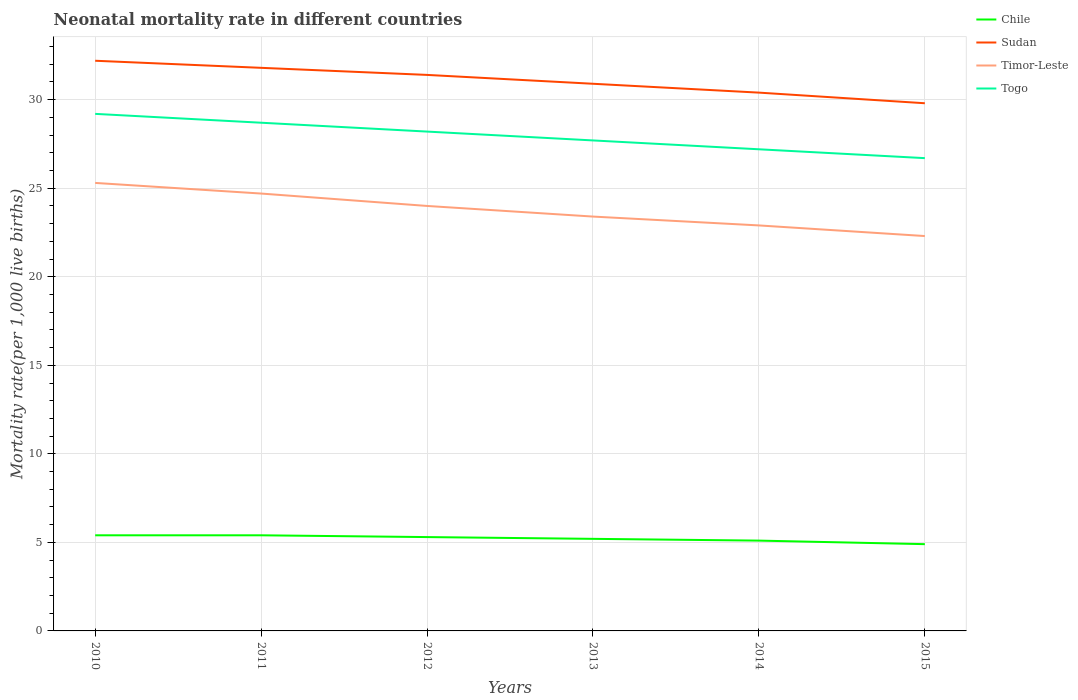How many different coloured lines are there?
Provide a short and direct response. 4. Is the number of lines equal to the number of legend labels?
Make the answer very short. Yes. Across all years, what is the maximum neonatal mortality rate in Sudan?
Make the answer very short. 29.8. In which year was the neonatal mortality rate in Togo maximum?
Ensure brevity in your answer.  2015. What is the total neonatal mortality rate in Timor-Leste in the graph?
Offer a terse response. 2.4. What is the difference between the highest and the second highest neonatal mortality rate in Timor-Leste?
Ensure brevity in your answer.  3. Does the graph contain any zero values?
Provide a short and direct response. No. How many legend labels are there?
Ensure brevity in your answer.  4. What is the title of the graph?
Your answer should be compact. Neonatal mortality rate in different countries. Does "Greenland" appear as one of the legend labels in the graph?
Your answer should be very brief. No. What is the label or title of the X-axis?
Give a very brief answer. Years. What is the label or title of the Y-axis?
Make the answer very short. Mortality rate(per 1,0 live births). What is the Mortality rate(per 1,000 live births) of Chile in 2010?
Keep it short and to the point. 5.4. What is the Mortality rate(per 1,000 live births) in Sudan in 2010?
Make the answer very short. 32.2. What is the Mortality rate(per 1,000 live births) in Timor-Leste in 2010?
Offer a terse response. 25.3. What is the Mortality rate(per 1,000 live births) of Togo in 2010?
Make the answer very short. 29.2. What is the Mortality rate(per 1,000 live births) of Sudan in 2011?
Your response must be concise. 31.8. What is the Mortality rate(per 1,000 live births) of Timor-Leste in 2011?
Give a very brief answer. 24.7. What is the Mortality rate(per 1,000 live births) of Togo in 2011?
Offer a terse response. 28.7. What is the Mortality rate(per 1,000 live births) of Sudan in 2012?
Make the answer very short. 31.4. What is the Mortality rate(per 1,000 live births) of Togo in 2012?
Keep it short and to the point. 28.2. What is the Mortality rate(per 1,000 live births) in Sudan in 2013?
Your response must be concise. 30.9. What is the Mortality rate(per 1,000 live births) in Timor-Leste in 2013?
Your answer should be very brief. 23.4. What is the Mortality rate(per 1,000 live births) of Togo in 2013?
Provide a succinct answer. 27.7. What is the Mortality rate(per 1,000 live births) in Chile in 2014?
Ensure brevity in your answer.  5.1. What is the Mortality rate(per 1,000 live births) of Sudan in 2014?
Offer a very short reply. 30.4. What is the Mortality rate(per 1,000 live births) of Timor-Leste in 2014?
Keep it short and to the point. 22.9. What is the Mortality rate(per 1,000 live births) in Togo in 2014?
Offer a very short reply. 27.2. What is the Mortality rate(per 1,000 live births) in Chile in 2015?
Make the answer very short. 4.9. What is the Mortality rate(per 1,000 live births) in Sudan in 2015?
Ensure brevity in your answer.  29.8. What is the Mortality rate(per 1,000 live births) in Timor-Leste in 2015?
Keep it short and to the point. 22.3. What is the Mortality rate(per 1,000 live births) in Togo in 2015?
Offer a very short reply. 26.7. Across all years, what is the maximum Mortality rate(per 1,000 live births) of Chile?
Make the answer very short. 5.4. Across all years, what is the maximum Mortality rate(per 1,000 live births) of Sudan?
Your response must be concise. 32.2. Across all years, what is the maximum Mortality rate(per 1,000 live births) of Timor-Leste?
Give a very brief answer. 25.3. Across all years, what is the maximum Mortality rate(per 1,000 live births) in Togo?
Offer a terse response. 29.2. Across all years, what is the minimum Mortality rate(per 1,000 live births) of Chile?
Your answer should be compact. 4.9. Across all years, what is the minimum Mortality rate(per 1,000 live births) in Sudan?
Your answer should be very brief. 29.8. Across all years, what is the minimum Mortality rate(per 1,000 live births) of Timor-Leste?
Give a very brief answer. 22.3. Across all years, what is the minimum Mortality rate(per 1,000 live births) in Togo?
Keep it short and to the point. 26.7. What is the total Mortality rate(per 1,000 live births) in Chile in the graph?
Offer a very short reply. 31.3. What is the total Mortality rate(per 1,000 live births) in Sudan in the graph?
Offer a very short reply. 186.5. What is the total Mortality rate(per 1,000 live births) of Timor-Leste in the graph?
Ensure brevity in your answer.  142.6. What is the total Mortality rate(per 1,000 live births) in Togo in the graph?
Give a very brief answer. 167.7. What is the difference between the Mortality rate(per 1,000 live births) in Chile in 2010 and that in 2011?
Your answer should be very brief. 0. What is the difference between the Mortality rate(per 1,000 live births) in Sudan in 2010 and that in 2011?
Offer a very short reply. 0.4. What is the difference between the Mortality rate(per 1,000 live births) in Togo in 2010 and that in 2011?
Offer a very short reply. 0.5. What is the difference between the Mortality rate(per 1,000 live births) of Sudan in 2010 and that in 2012?
Provide a short and direct response. 0.8. What is the difference between the Mortality rate(per 1,000 live births) of Togo in 2010 and that in 2012?
Provide a succinct answer. 1. What is the difference between the Mortality rate(per 1,000 live births) in Sudan in 2010 and that in 2013?
Make the answer very short. 1.3. What is the difference between the Mortality rate(per 1,000 live births) of Togo in 2010 and that in 2013?
Your answer should be very brief. 1.5. What is the difference between the Mortality rate(per 1,000 live births) in Chile in 2010 and that in 2014?
Ensure brevity in your answer.  0.3. What is the difference between the Mortality rate(per 1,000 live births) of Sudan in 2010 and that in 2014?
Your answer should be compact. 1.8. What is the difference between the Mortality rate(per 1,000 live births) in Chile in 2010 and that in 2015?
Provide a succinct answer. 0.5. What is the difference between the Mortality rate(per 1,000 live births) of Timor-Leste in 2010 and that in 2015?
Your response must be concise. 3. What is the difference between the Mortality rate(per 1,000 live births) in Togo in 2010 and that in 2015?
Keep it short and to the point. 2.5. What is the difference between the Mortality rate(per 1,000 live births) of Chile in 2011 and that in 2012?
Your answer should be very brief. 0.1. What is the difference between the Mortality rate(per 1,000 live births) of Sudan in 2011 and that in 2012?
Your answer should be very brief. 0.4. What is the difference between the Mortality rate(per 1,000 live births) of Timor-Leste in 2011 and that in 2012?
Provide a succinct answer. 0.7. What is the difference between the Mortality rate(per 1,000 live births) in Togo in 2011 and that in 2013?
Provide a succinct answer. 1. What is the difference between the Mortality rate(per 1,000 live births) in Sudan in 2011 and that in 2014?
Make the answer very short. 1.4. What is the difference between the Mortality rate(per 1,000 live births) of Chile in 2011 and that in 2015?
Your answer should be very brief. 0.5. What is the difference between the Mortality rate(per 1,000 live births) of Timor-Leste in 2011 and that in 2015?
Offer a terse response. 2.4. What is the difference between the Mortality rate(per 1,000 live births) in Sudan in 2012 and that in 2013?
Your answer should be compact. 0.5. What is the difference between the Mortality rate(per 1,000 live births) in Chile in 2012 and that in 2014?
Your response must be concise. 0.2. What is the difference between the Mortality rate(per 1,000 live births) of Timor-Leste in 2012 and that in 2014?
Keep it short and to the point. 1.1. What is the difference between the Mortality rate(per 1,000 live births) in Togo in 2012 and that in 2014?
Your answer should be compact. 1. What is the difference between the Mortality rate(per 1,000 live births) in Sudan in 2012 and that in 2015?
Make the answer very short. 1.6. What is the difference between the Mortality rate(per 1,000 live births) of Chile in 2013 and that in 2014?
Make the answer very short. 0.1. What is the difference between the Mortality rate(per 1,000 live births) in Sudan in 2013 and that in 2014?
Make the answer very short. 0.5. What is the difference between the Mortality rate(per 1,000 live births) of Togo in 2013 and that in 2014?
Offer a very short reply. 0.5. What is the difference between the Mortality rate(per 1,000 live births) in Togo in 2013 and that in 2015?
Keep it short and to the point. 1. What is the difference between the Mortality rate(per 1,000 live births) in Sudan in 2014 and that in 2015?
Keep it short and to the point. 0.6. What is the difference between the Mortality rate(per 1,000 live births) of Chile in 2010 and the Mortality rate(per 1,000 live births) of Sudan in 2011?
Offer a very short reply. -26.4. What is the difference between the Mortality rate(per 1,000 live births) of Chile in 2010 and the Mortality rate(per 1,000 live births) of Timor-Leste in 2011?
Provide a short and direct response. -19.3. What is the difference between the Mortality rate(per 1,000 live births) of Chile in 2010 and the Mortality rate(per 1,000 live births) of Togo in 2011?
Ensure brevity in your answer.  -23.3. What is the difference between the Mortality rate(per 1,000 live births) in Sudan in 2010 and the Mortality rate(per 1,000 live births) in Timor-Leste in 2011?
Offer a terse response. 7.5. What is the difference between the Mortality rate(per 1,000 live births) in Timor-Leste in 2010 and the Mortality rate(per 1,000 live births) in Togo in 2011?
Ensure brevity in your answer.  -3.4. What is the difference between the Mortality rate(per 1,000 live births) of Chile in 2010 and the Mortality rate(per 1,000 live births) of Timor-Leste in 2012?
Offer a very short reply. -18.6. What is the difference between the Mortality rate(per 1,000 live births) of Chile in 2010 and the Mortality rate(per 1,000 live births) of Togo in 2012?
Give a very brief answer. -22.8. What is the difference between the Mortality rate(per 1,000 live births) in Timor-Leste in 2010 and the Mortality rate(per 1,000 live births) in Togo in 2012?
Your response must be concise. -2.9. What is the difference between the Mortality rate(per 1,000 live births) in Chile in 2010 and the Mortality rate(per 1,000 live births) in Sudan in 2013?
Provide a succinct answer. -25.5. What is the difference between the Mortality rate(per 1,000 live births) of Chile in 2010 and the Mortality rate(per 1,000 live births) of Timor-Leste in 2013?
Your response must be concise. -18. What is the difference between the Mortality rate(per 1,000 live births) in Chile in 2010 and the Mortality rate(per 1,000 live births) in Togo in 2013?
Keep it short and to the point. -22.3. What is the difference between the Mortality rate(per 1,000 live births) of Timor-Leste in 2010 and the Mortality rate(per 1,000 live births) of Togo in 2013?
Ensure brevity in your answer.  -2.4. What is the difference between the Mortality rate(per 1,000 live births) in Chile in 2010 and the Mortality rate(per 1,000 live births) in Timor-Leste in 2014?
Offer a terse response. -17.5. What is the difference between the Mortality rate(per 1,000 live births) in Chile in 2010 and the Mortality rate(per 1,000 live births) in Togo in 2014?
Your response must be concise. -21.8. What is the difference between the Mortality rate(per 1,000 live births) in Timor-Leste in 2010 and the Mortality rate(per 1,000 live births) in Togo in 2014?
Offer a terse response. -1.9. What is the difference between the Mortality rate(per 1,000 live births) in Chile in 2010 and the Mortality rate(per 1,000 live births) in Sudan in 2015?
Keep it short and to the point. -24.4. What is the difference between the Mortality rate(per 1,000 live births) of Chile in 2010 and the Mortality rate(per 1,000 live births) of Timor-Leste in 2015?
Give a very brief answer. -16.9. What is the difference between the Mortality rate(per 1,000 live births) in Chile in 2010 and the Mortality rate(per 1,000 live births) in Togo in 2015?
Ensure brevity in your answer.  -21.3. What is the difference between the Mortality rate(per 1,000 live births) of Sudan in 2010 and the Mortality rate(per 1,000 live births) of Togo in 2015?
Provide a succinct answer. 5.5. What is the difference between the Mortality rate(per 1,000 live births) in Timor-Leste in 2010 and the Mortality rate(per 1,000 live births) in Togo in 2015?
Your answer should be compact. -1.4. What is the difference between the Mortality rate(per 1,000 live births) in Chile in 2011 and the Mortality rate(per 1,000 live births) in Timor-Leste in 2012?
Provide a succinct answer. -18.6. What is the difference between the Mortality rate(per 1,000 live births) in Chile in 2011 and the Mortality rate(per 1,000 live births) in Togo in 2012?
Offer a terse response. -22.8. What is the difference between the Mortality rate(per 1,000 live births) of Sudan in 2011 and the Mortality rate(per 1,000 live births) of Timor-Leste in 2012?
Your answer should be very brief. 7.8. What is the difference between the Mortality rate(per 1,000 live births) in Sudan in 2011 and the Mortality rate(per 1,000 live births) in Togo in 2012?
Make the answer very short. 3.6. What is the difference between the Mortality rate(per 1,000 live births) of Chile in 2011 and the Mortality rate(per 1,000 live births) of Sudan in 2013?
Ensure brevity in your answer.  -25.5. What is the difference between the Mortality rate(per 1,000 live births) in Chile in 2011 and the Mortality rate(per 1,000 live births) in Togo in 2013?
Provide a succinct answer. -22.3. What is the difference between the Mortality rate(per 1,000 live births) in Sudan in 2011 and the Mortality rate(per 1,000 live births) in Togo in 2013?
Offer a very short reply. 4.1. What is the difference between the Mortality rate(per 1,000 live births) of Chile in 2011 and the Mortality rate(per 1,000 live births) of Timor-Leste in 2014?
Keep it short and to the point. -17.5. What is the difference between the Mortality rate(per 1,000 live births) in Chile in 2011 and the Mortality rate(per 1,000 live births) in Togo in 2014?
Provide a short and direct response. -21.8. What is the difference between the Mortality rate(per 1,000 live births) of Chile in 2011 and the Mortality rate(per 1,000 live births) of Sudan in 2015?
Your answer should be compact. -24.4. What is the difference between the Mortality rate(per 1,000 live births) of Chile in 2011 and the Mortality rate(per 1,000 live births) of Timor-Leste in 2015?
Keep it short and to the point. -16.9. What is the difference between the Mortality rate(per 1,000 live births) of Chile in 2011 and the Mortality rate(per 1,000 live births) of Togo in 2015?
Your answer should be compact. -21.3. What is the difference between the Mortality rate(per 1,000 live births) of Sudan in 2011 and the Mortality rate(per 1,000 live births) of Timor-Leste in 2015?
Offer a very short reply. 9.5. What is the difference between the Mortality rate(per 1,000 live births) of Sudan in 2011 and the Mortality rate(per 1,000 live births) of Togo in 2015?
Provide a succinct answer. 5.1. What is the difference between the Mortality rate(per 1,000 live births) of Chile in 2012 and the Mortality rate(per 1,000 live births) of Sudan in 2013?
Offer a very short reply. -25.6. What is the difference between the Mortality rate(per 1,000 live births) of Chile in 2012 and the Mortality rate(per 1,000 live births) of Timor-Leste in 2013?
Give a very brief answer. -18.1. What is the difference between the Mortality rate(per 1,000 live births) in Chile in 2012 and the Mortality rate(per 1,000 live births) in Togo in 2013?
Give a very brief answer. -22.4. What is the difference between the Mortality rate(per 1,000 live births) of Timor-Leste in 2012 and the Mortality rate(per 1,000 live births) of Togo in 2013?
Provide a short and direct response. -3.7. What is the difference between the Mortality rate(per 1,000 live births) in Chile in 2012 and the Mortality rate(per 1,000 live births) in Sudan in 2014?
Your answer should be compact. -25.1. What is the difference between the Mortality rate(per 1,000 live births) of Chile in 2012 and the Mortality rate(per 1,000 live births) of Timor-Leste in 2014?
Provide a short and direct response. -17.6. What is the difference between the Mortality rate(per 1,000 live births) of Chile in 2012 and the Mortality rate(per 1,000 live births) of Togo in 2014?
Your answer should be very brief. -21.9. What is the difference between the Mortality rate(per 1,000 live births) of Sudan in 2012 and the Mortality rate(per 1,000 live births) of Togo in 2014?
Ensure brevity in your answer.  4.2. What is the difference between the Mortality rate(per 1,000 live births) in Chile in 2012 and the Mortality rate(per 1,000 live births) in Sudan in 2015?
Your answer should be compact. -24.5. What is the difference between the Mortality rate(per 1,000 live births) of Chile in 2012 and the Mortality rate(per 1,000 live births) of Togo in 2015?
Offer a very short reply. -21.4. What is the difference between the Mortality rate(per 1,000 live births) of Sudan in 2012 and the Mortality rate(per 1,000 live births) of Timor-Leste in 2015?
Offer a very short reply. 9.1. What is the difference between the Mortality rate(per 1,000 live births) in Chile in 2013 and the Mortality rate(per 1,000 live births) in Sudan in 2014?
Ensure brevity in your answer.  -25.2. What is the difference between the Mortality rate(per 1,000 live births) in Chile in 2013 and the Mortality rate(per 1,000 live births) in Timor-Leste in 2014?
Give a very brief answer. -17.7. What is the difference between the Mortality rate(per 1,000 live births) in Chile in 2013 and the Mortality rate(per 1,000 live births) in Togo in 2014?
Offer a terse response. -22. What is the difference between the Mortality rate(per 1,000 live births) of Sudan in 2013 and the Mortality rate(per 1,000 live births) of Timor-Leste in 2014?
Your answer should be very brief. 8. What is the difference between the Mortality rate(per 1,000 live births) of Chile in 2013 and the Mortality rate(per 1,000 live births) of Sudan in 2015?
Keep it short and to the point. -24.6. What is the difference between the Mortality rate(per 1,000 live births) in Chile in 2013 and the Mortality rate(per 1,000 live births) in Timor-Leste in 2015?
Offer a very short reply. -17.1. What is the difference between the Mortality rate(per 1,000 live births) of Chile in 2013 and the Mortality rate(per 1,000 live births) of Togo in 2015?
Provide a short and direct response. -21.5. What is the difference between the Mortality rate(per 1,000 live births) in Sudan in 2013 and the Mortality rate(per 1,000 live births) in Timor-Leste in 2015?
Ensure brevity in your answer.  8.6. What is the difference between the Mortality rate(per 1,000 live births) in Timor-Leste in 2013 and the Mortality rate(per 1,000 live births) in Togo in 2015?
Your answer should be very brief. -3.3. What is the difference between the Mortality rate(per 1,000 live births) of Chile in 2014 and the Mortality rate(per 1,000 live births) of Sudan in 2015?
Offer a terse response. -24.7. What is the difference between the Mortality rate(per 1,000 live births) in Chile in 2014 and the Mortality rate(per 1,000 live births) in Timor-Leste in 2015?
Provide a succinct answer. -17.2. What is the difference between the Mortality rate(per 1,000 live births) in Chile in 2014 and the Mortality rate(per 1,000 live births) in Togo in 2015?
Your answer should be very brief. -21.6. What is the difference between the Mortality rate(per 1,000 live births) in Sudan in 2014 and the Mortality rate(per 1,000 live births) in Timor-Leste in 2015?
Give a very brief answer. 8.1. What is the difference between the Mortality rate(per 1,000 live births) of Sudan in 2014 and the Mortality rate(per 1,000 live births) of Togo in 2015?
Keep it short and to the point. 3.7. What is the difference between the Mortality rate(per 1,000 live births) of Timor-Leste in 2014 and the Mortality rate(per 1,000 live births) of Togo in 2015?
Provide a succinct answer. -3.8. What is the average Mortality rate(per 1,000 live births) of Chile per year?
Make the answer very short. 5.22. What is the average Mortality rate(per 1,000 live births) of Sudan per year?
Ensure brevity in your answer.  31.08. What is the average Mortality rate(per 1,000 live births) of Timor-Leste per year?
Keep it short and to the point. 23.77. What is the average Mortality rate(per 1,000 live births) of Togo per year?
Offer a very short reply. 27.95. In the year 2010, what is the difference between the Mortality rate(per 1,000 live births) of Chile and Mortality rate(per 1,000 live births) of Sudan?
Your answer should be compact. -26.8. In the year 2010, what is the difference between the Mortality rate(per 1,000 live births) in Chile and Mortality rate(per 1,000 live births) in Timor-Leste?
Keep it short and to the point. -19.9. In the year 2010, what is the difference between the Mortality rate(per 1,000 live births) of Chile and Mortality rate(per 1,000 live births) of Togo?
Your answer should be very brief. -23.8. In the year 2010, what is the difference between the Mortality rate(per 1,000 live births) of Sudan and Mortality rate(per 1,000 live births) of Timor-Leste?
Your answer should be very brief. 6.9. In the year 2010, what is the difference between the Mortality rate(per 1,000 live births) in Sudan and Mortality rate(per 1,000 live births) in Togo?
Offer a very short reply. 3. In the year 2011, what is the difference between the Mortality rate(per 1,000 live births) of Chile and Mortality rate(per 1,000 live births) of Sudan?
Give a very brief answer. -26.4. In the year 2011, what is the difference between the Mortality rate(per 1,000 live births) of Chile and Mortality rate(per 1,000 live births) of Timor-Leste?
Your answer should be very brief. -19.3. In the year 2011, what is the difference between the Mortality rate(per 1,000 live births) of Chile and Mortality rate(per 1,000 live births) of Togo?
Your answer should be very brief. -23.3. In the year 2011, what is the difference between the Mortality rate(per 1,000 live births) of Timor-Leste and Mortality rate(per 1,000 live births) of Togo?
Keep it short and to the point. -4. In the year 2012, what is the difference between the Mortality rate(per 1,000 live births) in Chile and Mortality rate(per 1,000 live births) in Sudan?
Give a very brief answer. -26.1. In the year 2012, what is the difference between the Mortality rate(per 1,000 live births) of Chile and Mortality rate(per 1,000 live births) of Timor-Leste?
Provide a succinct answer. -18.7. In the year 2012, what is the difference between the Mortality rate(per 1,000 live births) in Chile and Mortality rate(per 1,000 live births) in Togo?
Give a very brief answer. -22.9. In the year 2012, what is the difference between the Mortality rate(per 1,000 live births) of Timor-Leste and Mortality rate(per 1,000 live births) of Togo?
Your answer should be very brief. -4.2. In the year 2013, what is the difference between the Mortality rate(per 1,000 live births) of Chile and Mortality rate(per 1,000 live births) of Sudan?
Ensure brevity in your answer.  -25.7. In the year 2013, what is the difference between the Mortality rate(per 1,000 live births) in Chile and Mortality rate(per 1,000 live births) in Timor-Leste?
Provide a short and direct response. -18.2. In the year 2013, what is the difference between the Mortality rate(per 1,000 live births) in Chile and Mortality rate(per 1,000 live births) in Togo?
Your response must be concise. -22.5. In the year 2013, what is the difference between the Mortality rate(per 1,000 live births) in Sudan and Mortality rate(per 1,000 live births) in Timor-Leste?
Your answer should be very brief. 7.5. In the year 2013, what is the difference between the Mortality rate(per 1,000 live births) in Timor-Leste and Mortality rate(per 1,000 live births) in Togo?
Offer a very short reply. -4.3. In the year 2014, what is the difference between the Mortality rate(per 1,000 live births) in Chile and Mortality rate(per 1,000 live births) in Sudan?
Ensure brevity in your answer.  -25.3. In the year 2014, what is the difference between the Mortality rate(per 1,000 live births) of Chile and Mortality rate(per 1,000 live births) of Timor-Leste?
Your answer should be very brief. -17.8. In the year 2014, what is the difference between the Mortality rate(per 1,000 live births) of Chile and Mortality rate(per 1,000 live births) of Togo?
Your answer should be very brief. -22.1. In the year 2014, what is the difference between the Mortality rate(per 1,000 live births) in Timor-Leste and Mortality rate(per 1,000 live births) in Togo?
Make the answer very short. -4.3. In the year 2015, what is the difference between the Mortality rate(per 1,000 live births) in Chile and Mortality rate(per 1,000 live births) in Sudan?
Offer a terse response. -24.9. In the year 2015, what is the difference between the Mortality rate(per 1,000 live births) of Chile and Mortality rate(per 1,000 live births) of Timor-Leste?
Give a very brief answer. -17.4. In the year 2015, what is the difference between the Mortality rate(per 1,000 live births) in Chile and Mortality rate(per 1,000 live births) in Togo?
Make the answer very short. -21.8. In the year 2015, what is the difference between the Mortality rate(per 1,000 live births) of Sudan and Mortality rate(per 1,000 live births) of Timor-Leste?
Your answer should be compact. 7.5. In the year 2015, what is the difference between the Mortality rate(per 1,000 live births) of Sudan and Mortality rate(per 1,000 live births) of Togo?
Provide a succinct answer. 3.1. What is the ratio of the Mortality rate(per 1,000 live births) in Chile in 2010 to that in 2011?
Offer a very short reply. 1. What is the ratio of the Mortality rate(per 1,000 live births) of Sudan in 2010 to that in 2011?
Your answer should be very brief. 1.01. What is the ratio of the Mortality rate(per 1,000 live births) of Timor-Leste in 2010 to that in 2011?
Offer a terse response. 1.02. What is the ratio of the Mortality rate(per 1,000 live births) of Togo in 2010 to that in 2011?
Your response must be concise. 1.02. What is the ratio of the Mortality rate(per 1,000 live births) of Chile in 2010 to that in 2012?
Ensure brevity in your answer.  1.02. What is the ratio of the Mortality rate(per 1,000 live births) in Sudan in 2010 to that in 2012?
Give a very brief answer. 1.03. What is the ratio of the Mortality rate(per 1,000 live births) in Timor-Leste in 2010 to that in 2012?
Make the answer very short. 1.05. What is the ratio of the Mortality rate(per 1,000 live births) of Togo in 2010 to that in 2012?
Make the answer very short. 1.04. What is the ratio of the Mortality rate(per 1,000 live births) of Sudan in 2010 to that in 2013?
Ensure brevity in your answer.  1.04. What is the ratio of the Mortality rate(per 1,000 live births) of Timor-Leste in 2010 to that in 2013?
Your answer should be compact. 1.08. What is the ratio of the Mortality rate(per 1,000 live births) of Togo in 2010 to that in 2013?
Provide a succinct answer. 1.05. What is the ratio of the Mortality rate(per 1,000 live births) of Chile in 2010 to that in 2014?
Offer a terse response. 1.06. What is the ratio of the Mortality rate(per 1,000 live births) of Sudan in 2010 to that in 2014?
Offer a terse response. 1.06. What is the ratio of the Mortality rate(per 1,000 live births) of Timor-Leste in 2010 to that in 2014?
Your answer should be very brief. 1.1. What is the ratio of the Mortality rate(per 1,000 live births) of Togo in 2010 to that in 2014?
Provide a short and direct response. 1.07. What is the ratio of the Mortality rate(per 1,000 live births) in Chile in 2010 to that in 2015?
Ensure brevity in your answer.  1.1. What is the ratio of the Mortality rate(per 1,000 live births) in Sudan in 2010 to that in 2015?
Your answer should be compact. 1.08. What is the ratio of the Mortality rate(per 1,000 live births) of Timor-Leste in 2010 to that in 2015?
Provide a short and direct response. 1.13. What is the ratio of the Mortality rate(per 1,000 live births) in Togo in 2010 to that in 2015?
Your answer should be compact. 1.09. What is the ratio of the Mortality rate(per 1,000 live births) of Chile in 2011 to that in 2012?
Your response must be concise. 1.02. What is the ratio of the Mortality rate(per 1,000 live births) in Sudan in 2011 to that in 2012?
Ensure brevity in your answer.  1.01. What is the ratio of the Mortality rate(per 1,000 live births) in Timor-Leste in 2011 to that in 2012?
Provide a succinct answer. 1.03. What is the ratio of the Mortality rate(per 1,000 live births) in Togo in 2011 to that in 2012?
Offer a very short reply. 1.02. What is the ratio of the Mortality rate(per 1,000 live births) in Chile in 2011 to that in 2013?
Your answer should be compact. 1.04. What is the ratio of the Mortality rate(per 1,000 live births) of Sudan in 2011 to that in 2013?
Your response must be concise. 1.03. What is the ratio of the Mortality rate(per 1,000 live births) in Timor-Leste in 2011 to that in 2013?
Provide a succinct answer. 1.06. What is the ratio of the Mortality rate(per 1,000 live births) in Togo in 2011 to that in 2013?
Offer a very short reply. 1.04. What is the ratio of the Mortality rate(per 1,000 live births) in Chile in 2011 to that in 2014?
Keep it short and to the point. 1.06. What is the ratio of the Mortality rate(per 1,000 live births) of Sudan in 2011 to that in 2014?
Keep it short and to the point. 1.05. What is the ratio of the Mortality rate(per 1,000 live births) in Timor-Leste in 2011 to that in 2014?
Offer a very short reply. 1.08. What is the ratio of the Mortality rate(per 1,000 live births) of Togo in 2011 to that in 2014?
Provide a short and direct response. 1.06. What is the ratio of the Mortality rate(per 1,000 live births) of Chile in 2011 to that in 2015?
Make the answer very short. 1.1. What is the ratio of the Mortality rate(per 1,000 live births) of Sudan in 2011 to that in 2015?
Provide a short and direct response. 1.07. What is the ratio of the Mortality rate(per 1,000 live births) of Timor-Leste in 2011 to that in 2015?
Provide a short and direct response. 1.11. What is the ratio of the Mortality rate(per 1,000 live births) of Togo in 2011 to that in 2015?
Offer a terse response. 1.07. What is the ratio of the Mortality rate(per 1,000 live births) in Chile in 2012 to that in 2013?
Keep it short and to the point. 1.02. What is the ratio of the Mortality rate(per 1,000 live births) of Sudan in 2012 to that in 2013?
Keep it short and to the point. 1.02. What is the ratio of the Mortality rate(per 1,000 live births) of Timor-Leste in 2012 to that in 2013?
Provide a short and direct response. 1.03. What is the ratio of the Mortality rate(per 1,000 live births) in Togo in 2012 to that in 2013?
Offer a terse response. 1.02. What is the ratio of the Mortality rate(per 1,000 live births) of Chile in 2012 to that in 2014?
Your answer should be compact. 1.04. What is the ratio of the Mortality rate(per 1,000 live births) of Sudan in 2012 to that in 2014?
Offer a terse response. 1.03. What is the ratio of the Mortality rate(per 1,000 live births) of Timor-Leste in 2012 to that in 2014?
Your answer should be compact. 1.05. What is the ratio of the Mortality rate(per 1,000 live births) of Togo in 2012 to that in 2014?
Give a very brief answer. 1.04. What is the ratio of the Mortality rate(per 1,000 live births) in Chile in 2012 to that in 2015?
Offer a terse response. 1.08. What is the ratio of the Mortality rate(per 1,000 live births) in Sudan in 2012 to that in 2015?
Offer a terse response. 1.05. What is the ratio of the Mortality rate(per 1,000 live births) in Timor-Leste in 2012 to that in 2015?
Provide a short and direct response. 1.08. What is the ratio of the Mortality rate(per 1,000 live births) of Togo in 2012 to that in 2015?
Offer a terse response. 1.06. What is the ratio of the Mortality rate(per 1,000 live births) in Chile in 2013 to that in 2014?
Provide a succinct answer. 1.02. What is the ratio of the Mortality rate(per 1,000 live births) in Sudan in 2013 to that in 2014?
Provide a short and direct response. 1.02. What is the ratio of the Mortality rate(per 1,000 live births) in Timor-Leste in 2013 to that in 2014?
Your response must be concise. 1.02. What is the ratio of the Mortality rate(per 1,000 live births) of Togo in 2013 to that in 2014?
Provide a succinct answer. 1.02. What is the ratio of the Mortality rate(per 1,000 live births) in Chile in 2013 to that in 2015?
Offer a terse response. 1.06. What is the ratio of the Mortality rate(per 1,000 live births) of Sudan in 2013 to that in 2015?
Keep it short and to the point. 1.04. What is the ratio of the Mortality rate(per 1,000 live births) of Timor-Leste in 2013 to that in 2015?
Your answer should be very brief. 1.05. What is the ratio of the Mortality rate(per 1,000 live births) in Togo in 2013 to that in 2015?
Keep it short and to the point. 1.04. What is the ratio of the Mortality rate(per 1,000 live births) of Chile in 2014 to that in 2015?
Provide a succinct answer. 1.04. What is the ratio of the Mortality rate(per 1,000 live births) of Sudan in 2014 to that in 2015?
Offer a terse response. 1.02. What is the ratio of the Mortality rate(per 1,000 live births) of Timor-Leste in 2014 to that in 2015?
Offer a very short reply. 1.03. What is the ratio of the Mortality rate(per 1,000 live births) of Togo in 2014 to that in 2015?
Your answer should be compact. 1.02. What is the difference between the highest and the second highest Mortality rate(per 1,000 live births) in Chile?
Give a very brief answer. 0. What is the difference between the highest and the second highest Mortality rate(per 1,000 live births) in Timor-Leste?
Provide a short and direct response. 0.6. What is the difference between the highest and the second highest Mortality rate(per 1,000 live births) in Togo?
Your answer should be compact. 0.5. What is the difference between the highest and the lowest Mortality rate(per 1,000 live births) in Sudan?
Your answer should be compact. 2.4. 